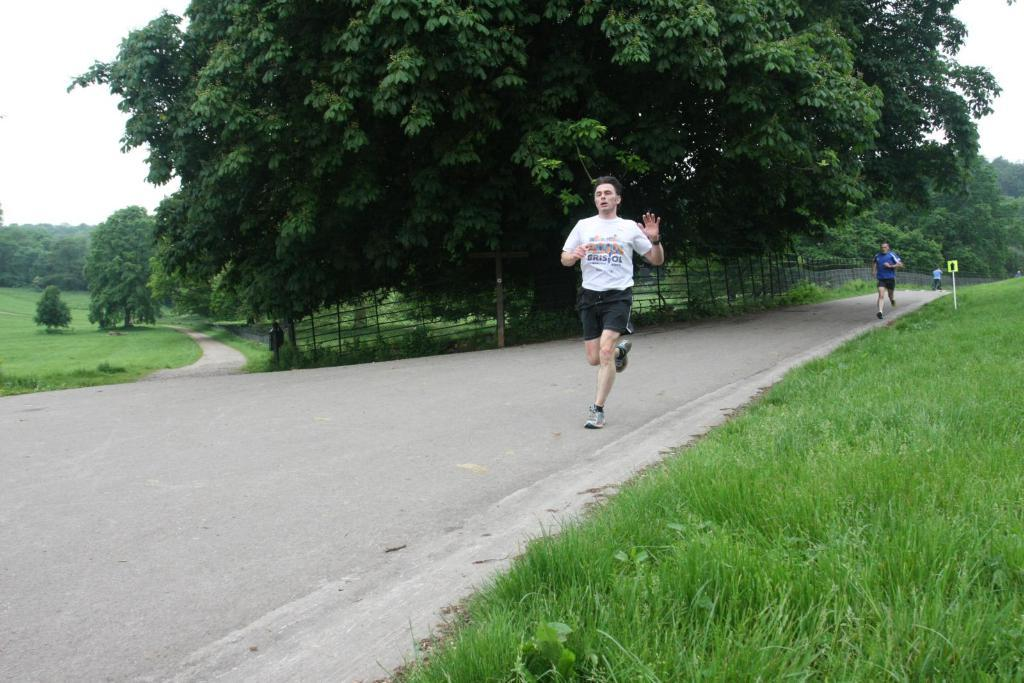How many people are in the image? There are people in the image, but the exact number is not specified. What are the people doing in the image? The people are running on the road in the image. What can be seen on the side of the road? There is a sign board in the image. What type of natural environment is visible in the image? There is grass, a fence, and trees in the image. What type of book is the person reading while running in the image? There is no person reading a book while running in the image. What is the person's interest in the image? The image does not provide information about the person's interests. 